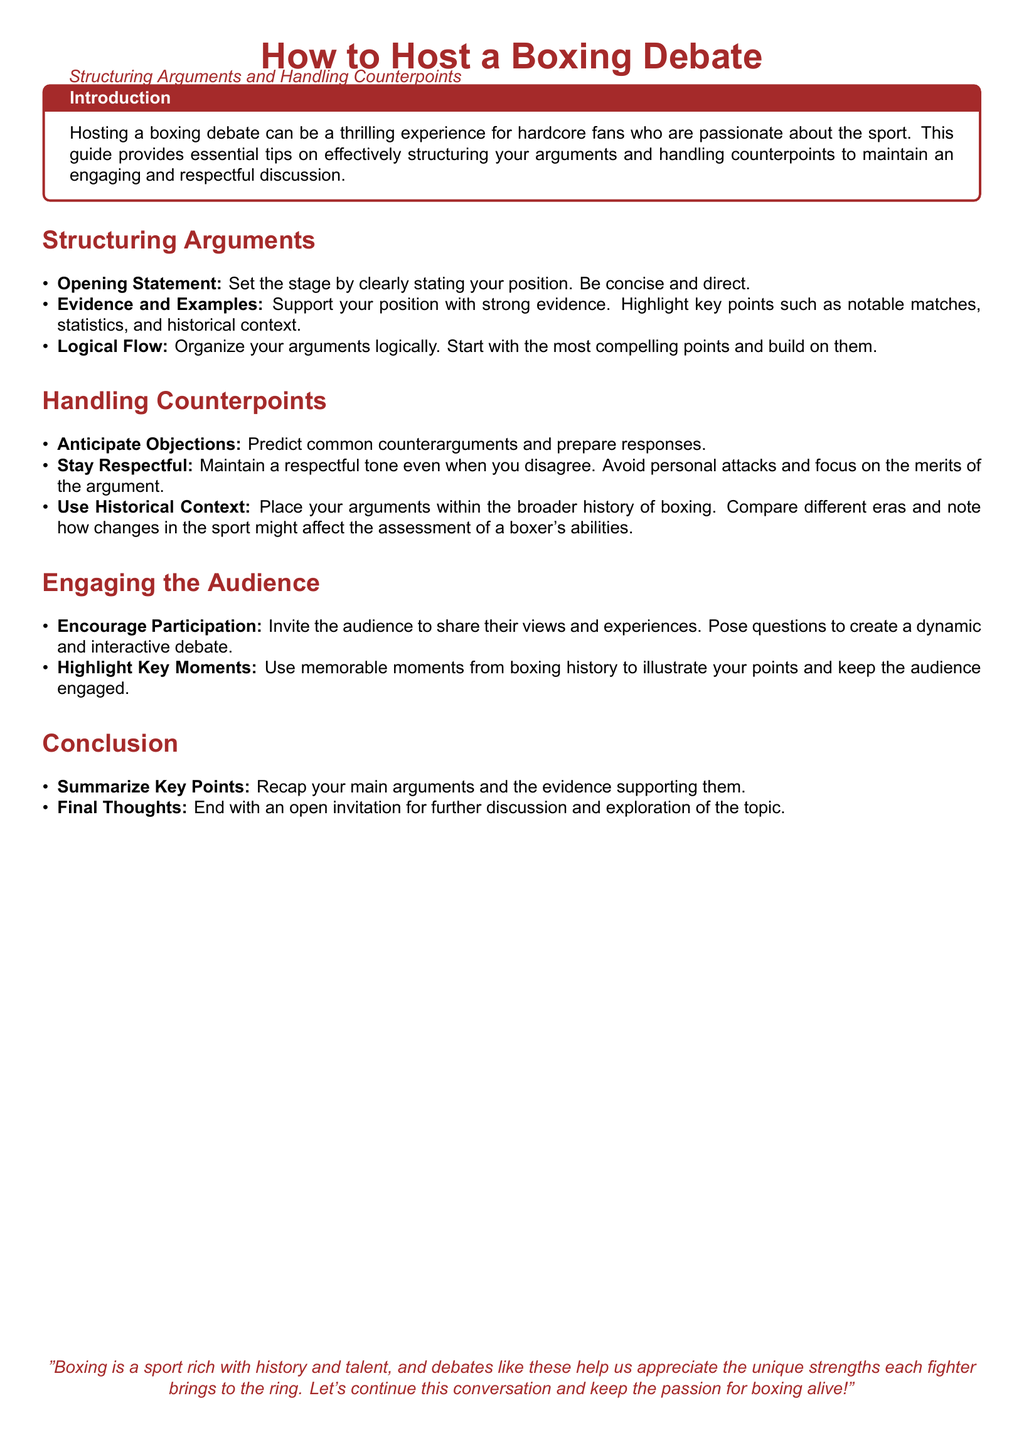What is the title of the guide? The title of the guide is found at the beginning of the document.
Answer: How to Host a Boxing Debate What section covers how to engage the audience? This section is specifically labeled in the document under that title.
Answer: Engaging the Audience What is the main focus of the introduction? The introduction sets the context for the guide and explains its purpose.
Answer: Tips on structuring arguments and handling counterpoints What is one way to handle counterpoints? This information is listed in a bullet point format within the relevant section.
Answer: Anticipate Objections Which color is used for the section titles? The document specifies a color code used for emphasizing titles.
Answer: Boxingred How should you conclude your arguments? The conclusion provides guidance on wrapping up your main points.
Answer: Summarize Key Points What is encouraged to foster a dynamic discussion? This is a recommendation found in the engagement section.
Answer: Encourage Participation How should you address disagreements in a debate? This is a guideline in the handling counterpoints section.
Answer: Stay Respectful 